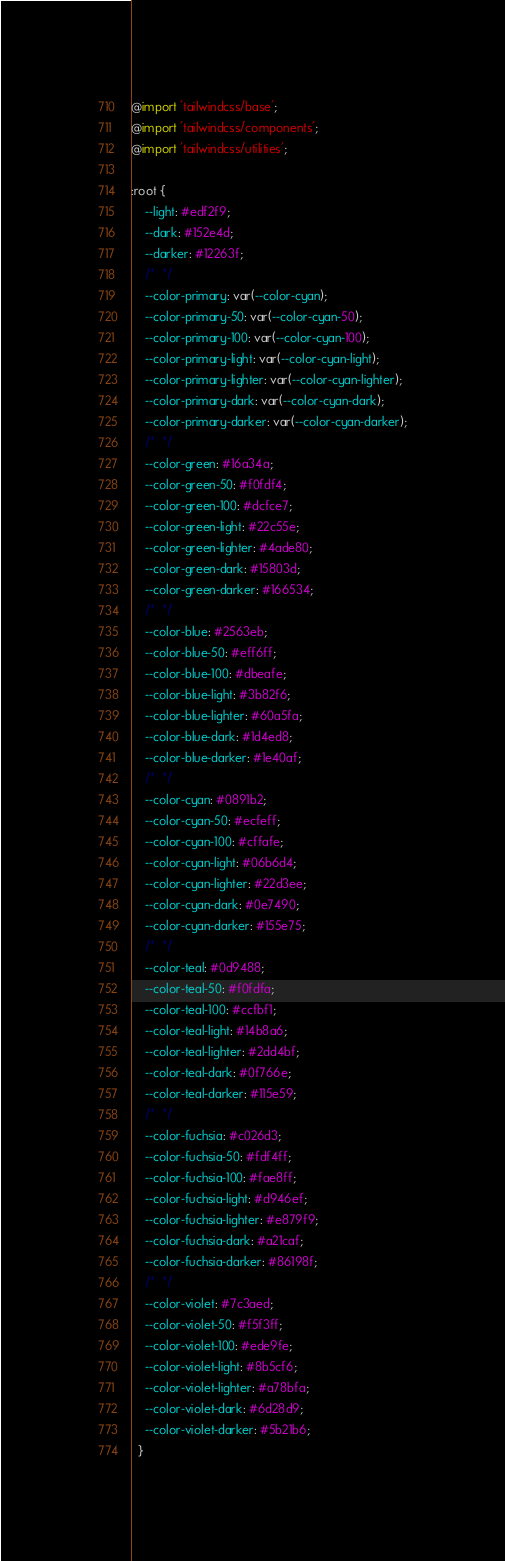Convert code to text. <code><loc_0><loc_0><loc_500><loc_500><_CSS_>@import 'tailwindcss/base';
@import 'tailwindcss/components';
@import 'tailwindcss/utilities';

:root {
    --light: #edf2f9;
    --dark: #152e4d;
    --darker: #12263f;
    /*  */
    --color-primary: var(--color-cyan);
    --color-primary-50: var(--color-cyan-50);
    --color-primary-100: var(--color-cyan-100);
    --color-primary-light: var(--color-cyan-light);
    --color-primary-lighter: var(--color-cyan-lighter);
    --color-primary-dark: var(--color-cyan-dark);
    --color-primary-darker: var(--color-cyan-darker);
    /*  */
    --color-green: #16a34a;
    --color-green-50: #f0fdf4;
    --color-green-100: #dcfce7;
    --color-green-light: #22c55e;
    --color-green-lighter: #4ade80;
    --color-green-dark: #15803d;
    --color-green-darker: #166534;
    /*  */
    --color-blue: #2563eb;
    --color-blue-50: #eff6ff;
    --color-blue-100: #dbeafe;
    --color-blue-light: #3b82f6;
    --color-blue-lighter: #60a5fa;
    --color-blue-dark: #1d4ed8;
    --color-blue-darker: #1e40af;
    /*  */
    --color-cyan: #0891b2;
    --color-cyan-50: #ecfeff;
    --color-cyan-100: #cffafe;
    --color-cyan-light: #06b6d4;
    --color-cyan-lighter: #22d3ee;
    --color-cyan-dark: #0e7490;
    --color-cyan-darker: #155e75;
    /*  */
    --color-teal: #0d9488;
    --color-teal-50: #f0fdfa;
    --color-teal-100: #ccfbf1;
    --color-teal-light: #14b8a6;
    --color-teal-lighter: #2dd4bf;
    --color-teal-dark: #0f766e;
    --color-teal-darker: #115e59;
    /*  */
    --color-fuchsia: #c026d3;
    --color-fuchsia-50: #fdf4ff;
    --color-fuchsia-100: #fae8ff;
    --color-fuchsia-light: #d946ef;
    --color-fuchsia-lighter: #e879f9;
    --color-fuchsia-dark: #a21caf;
    --color-fuchsia-darker: #86198f;
    /*  */
    --color-violet: #7c3aed;
    --color-violet-50: #f5f3ff;
    --color-violet-100: #ede9fe;
    --color-violet-light: #8b5cf6;
    --color-violet-lighter: #a78bfa;
    --color-violet-dark: #6d28d9;
    --color-violet-darker: #5b21b6;
  }</code> 